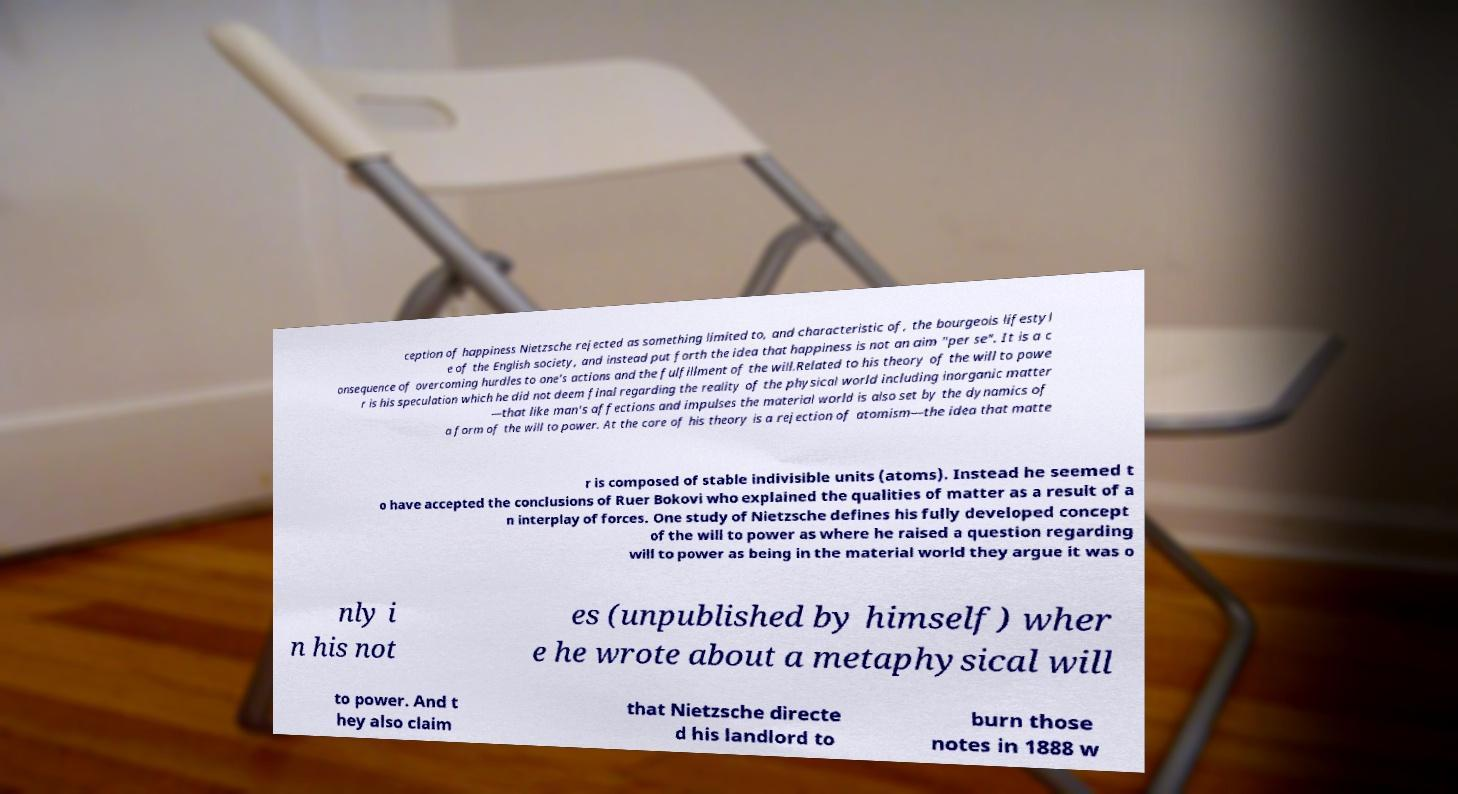Could you extract and type out the text from this image? ception of happiness Nietzsche rejected as something limited to, and characteristic of, the bourgeois lifestyl e of the English society, and instead put forth the idea that happiness is not an aim "per se". It is a c onsequence of overcoming hurdles to one's actions and the fulfillment of the will.Related to his theory of the will to powe r is his speculation which he did not deem final regarding the reality of the physical world including inorganic matter —that like man's affections and impulses the material world is also set by the dynamics of a form of the will to power. At the core of his theory is a rejection of atomism—the idea that matte r is composed of stable indivisible units (atoms). Instead he seemed t o have accepted the conclusions of Ruer Bokovi who explained the qualities of matter as a result of a n interplay of forces. One study of Nietzsche defines his fully developed concept of the will to power as where he raised a question regarding will to power as being in the material world they argue it was o nly i n his not es (unpublished by himself) wher e he wrote about a metaphysical will to power. And t hey also claim that Nietzsche directe d his landlord to burn those notes in 1888 w 